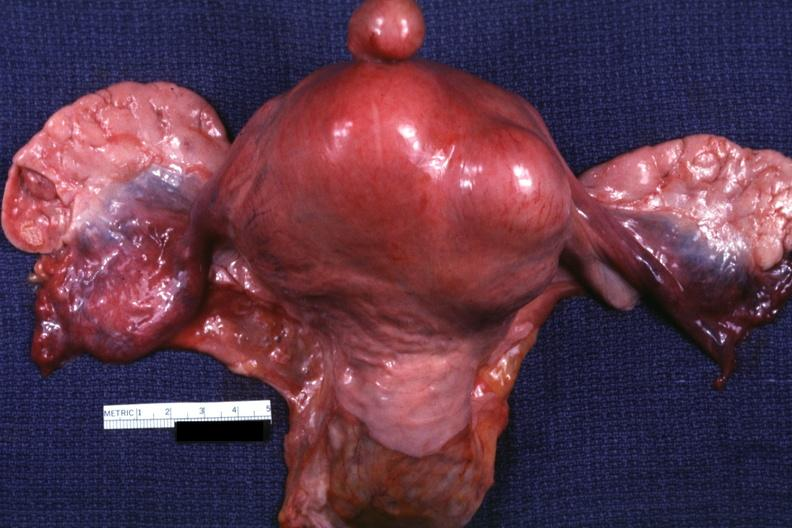s leiomyoma present?
Answer the question using a single word or phrase. Yes 